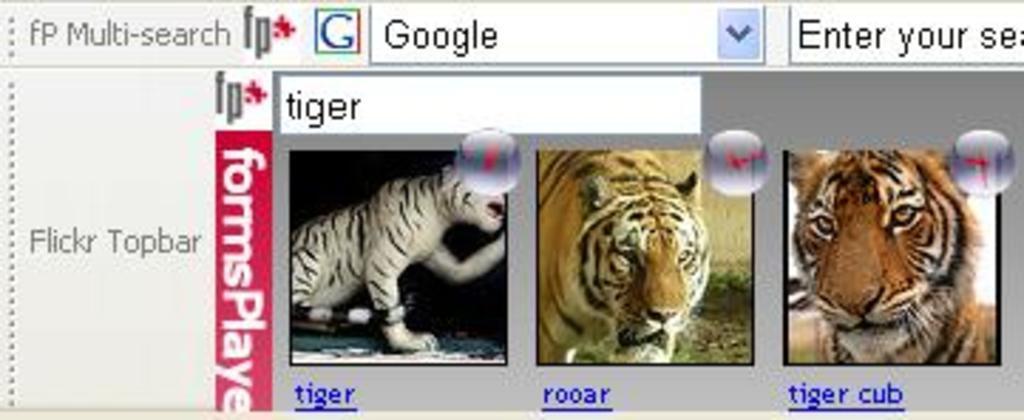Could you give a brief overview of what you see in this image? In this picture I can see a web page and I see something is written. I can also see 3 pictures of tigers. 